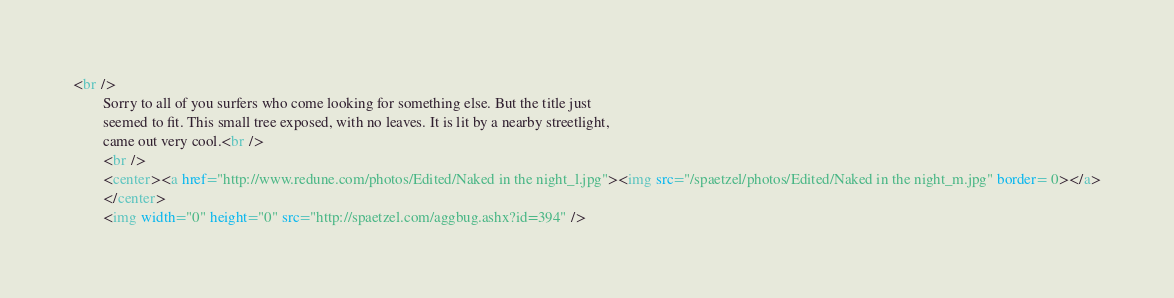<code> <loc_0><loc_0><loc_500><loc_500><_HTML_><br />
        Sorry to all of you surfers who come looking for something else. But the title just
        seemed to fit. This small tree exposed, with no leaves. It is lit by a nearby streetlight,
        came out very cool.<br />
        <br />
        <center><a href="http://www.redune.com/photos/Edited/Naked in the night_l.jpg"><img src="/spaetzel/photos/Edited/Naked in the night_m.jpg" border= 0></a>
        </center>
        <img width="0" height="0" src="http://spaetzel.com/aggbug.ashx?id=394" />
</code> 